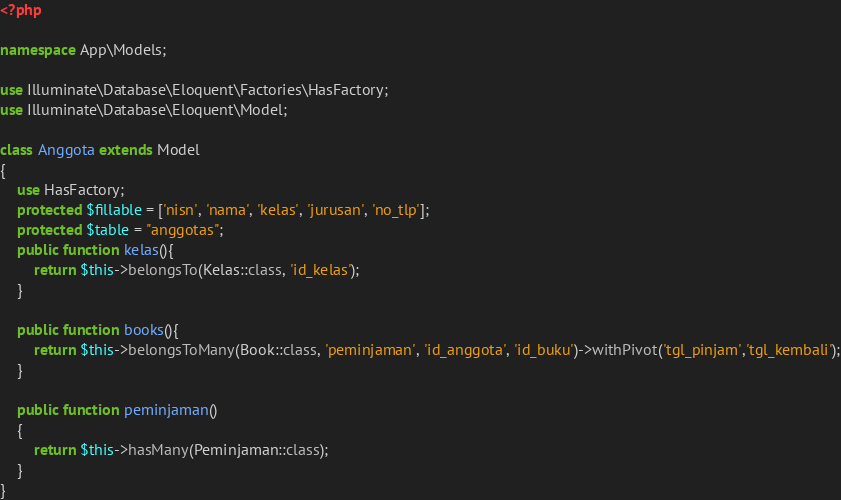<code> <loc_0><loc_0><loc_500><loc_500><_PHP_><?php

namespace App\Models;

use Illuminate\Database\Eloquent\Factories\HasFactory;
use Illuminate\Database\Eloquent\Model;

class Anggota extends Model
{
    use HasFactory;
    protected $fillable = ['nisn', 'nama', 'kelas', 'jurusan', 'no_tlp'];
    protected $table = "anggotas";
    public function kelas(){
        return $this->belongsTo(Kelas::class, 'id_kelas');
    }
    
    public function books(){
        return $this->belongsToMany(Book::class, 'peminjaman', 'id_anggota', 'id_buku')->withPivot('tgl_pinjam','tgl_kembali');
    }

    public function peminjaman()
    {
        return $this->hasMany(Peminjaman::class);
    }
}
</code> 